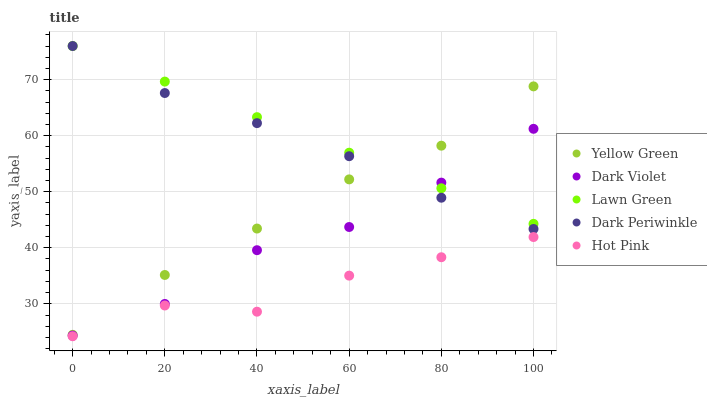Does Hot Pink have the minimum area under the curve?
Answer yes or no. Yes. Does Lawn Green have the maximum area under the curve?
Answer yes or no. Yes. Does Yellow Green have the minimum area under the curve?
Answer yes or no. No. Does Yellow Green have the maximum area under the curve?
Answer yes or no. No. Is Lawn Green the smoothest?
Answer yes or no. Yes. Is Hot Pink the roughest?
Answer yes or no. Yes. Is Yellow Green the smoothest?
Answer yes or no. No. Is Yellow Green the roughest?
Answer yes or no. No. Does Hot Pink have the lowest value?
Answer yes or no. Yes. Does Yellow Green have the lowest value?
Answer yes or no. No. Does Dark Periwinkle have the highest value?
Answer yes or no. Yes. Does Yellow Green have the highest value?
Answer yes or no. No. Is Dark Violet less than Yellow Green?
Answer yes or no. Yes. Is Dark Periwinkle greater than Hot Pink?
Answer yes or no. Yes. Does Dark Violet intersect Lawn Green?
Answer yes or no. Yes. Is Dark Violet less than Lawn Green?
Answer yes or no. No. Is Dark Violet greater than Lawn Green?
Answer yes or no. No. Does Dark Violet intersect Yellow Green?
Answer yes or no. No. 